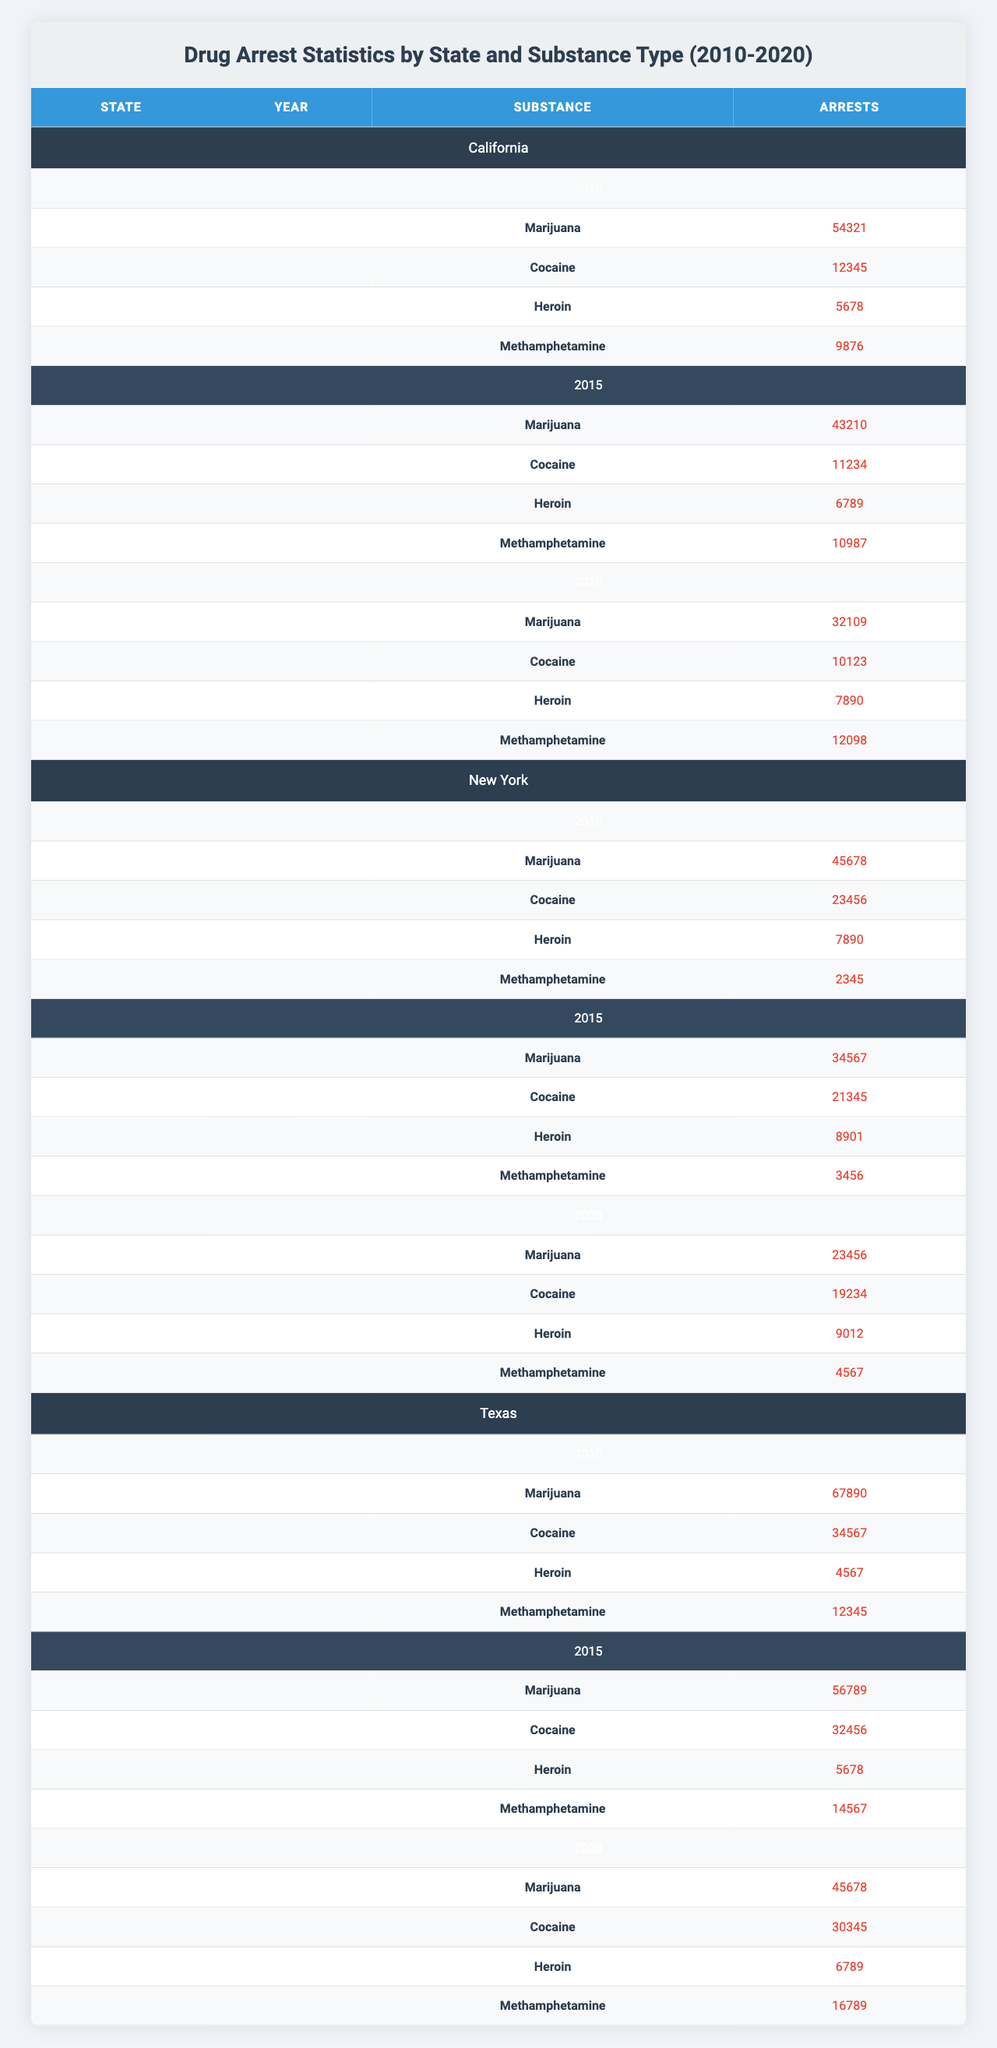What is the total number of marijuana arrests in California in 2010? In the table, California had 54,321 marijuana arrests in 2010 as indicated in the data presented under that year and substance type.
Answer: 54321 Which state had the highest number of cocaine arrests in 2015? By checking the data for 2015, Texas had 32,456 cocaine arrests, which is higher than California (11,234) and New York (21,345). Therefore, Texas had the highest number.
Answer: Texas What was the trend in marijuana arrests in California from 2010 to 2020? The numbers for California were 54,321 in 2010, 43,210 in 2015, and 32,109 in 2020. This shows a decreasing trend over the ten years.
Answer: Decreasing How many total drug arrests were made for methamphetamine in Texas in 2020? For Texas in 2020, there were 16,789 methamphetamine arrests reported in the table for that year and substance type.
Answer: 16789 In which year did New York have the highest arrests for heroin? By examining the table, New York had the highest heroin arrests in 2015 with 8,901. In 2010, it was 7,890, and in 2020, it was 9,012, which is lower.
Answer: 2015 What is the average number of cocaine arrests across all states for the year 2020? The total cocaine arrests for 2020 are calculated as follows: California 10,123 + New York 19,234 + Texas 30,345 = 59,702. Dividing by 3 states gives an average of 59,702/3 = 19,900.67.
Answer: 19900.67 Did any state have more than 50,000 total drug arrests in 2010? By summing the total arrests from all substances in 2010 for each state (California: 54,321 + New York: 45,678 + Texas: 67,890), the total is 167,889, which is greater than 50,000.
Answer: Yes Which drug type had the lowest total arrests in New York in 2020? In 2020, looking across the substances: Marijuana (23,456), Cocaine (19,234), Heroin (9,012), Methamphetamine (4,567). Methamphetamine had the lowest arrest total.
Answer: Methamphetamine What percentage of total drug arrests in California in 2010 were for cocaine? California had a total of 54,321 (marijuana) + 12,345 (cocaine) + 5,678 (heroin) + 9,876 (methamphetamine) = 82,220 total arrests. The percentage of cocaine is (12,345 / 82,220) * 100 = 15.03%.
Answer: 15.03% How many more marijuana arrests were made in Texas compared to New York in 2015? In 2015, Texas had 56,789 marijuana arrests and New York had 34,567. The difference is 56,789 - 34,567 = 22,222.
Answer: 22222 